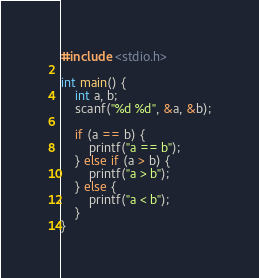<code> <loc_0><loc_0><loc_500><loc_500><_C++_>#include <stdio.h>

int main() {
    int a, b;
	scanf("%d %d", &a, &b);

	if (a == b) {
	    printf("a == b");
	} else if (a > b) {
	    printf("a > b");
	} else {
	    printf("a < b");
	}
}

</code> 